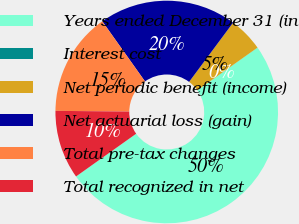<chart> <loc_0><loc_0><loc_500><loc_500><pie_chart><fcel>Years ended December 31 (in<fcel>Interest cost<fcel>Net periodic benefit (income)<fcel>Net actuarial loss (gain)<fcel>Total pre-tax changes<fcel>Total recognized in net<nl><fcel>49.98%<fcel>0.01%<fcel>5.01%<fcel>20.0%<fcel>15.0%<fcel>10.0%<nl></chart> 